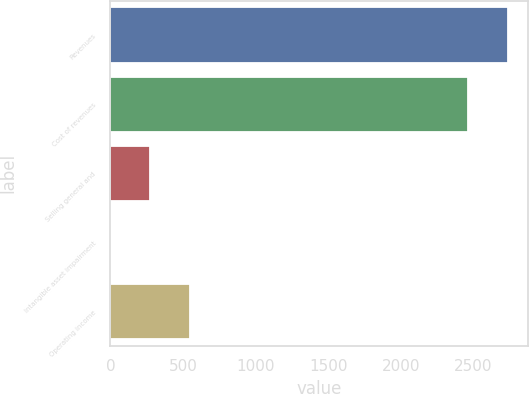Convert chart. <chart><loc_0><loc_0><loc_500><loc_500><bar_chart><fcel>Revenues<fcel>Cost of revenues<fcel>Selling general and<fcel>Intangible asset impairment<fcel>Operating income<nl><fcel>2737.6<fcel>2465<fcel>274.6<fcel>2<fcel>547.2<nl></chart> 